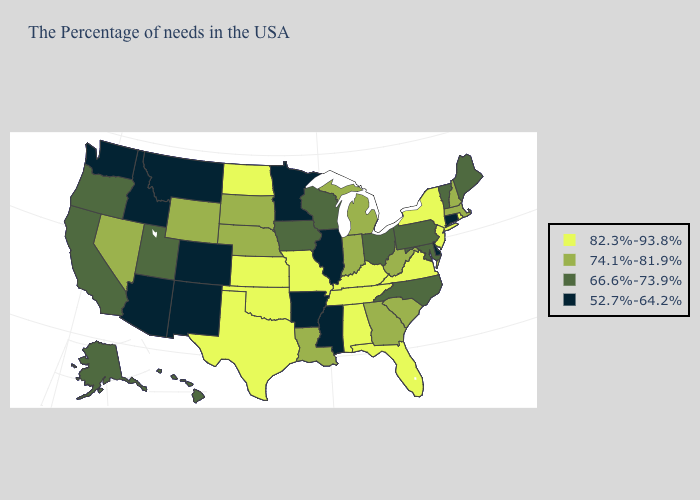What is the value of New Mexico?
Short answer required. 52.7%-64.2%. How many symbols are there in the legend?
Write a very short answer. 4. Among the states that border Connecticut , does New York have the highest value?
Answer briefly. Yes. Does Colorado have the highest value in the USA?
Keep it brief. No. Does the map have missing data?
Keep it brief. No. Does Oklahoma have the same value as Texas?
Give a very brief answer. Yes. Does Connecticut have the lowest value in the Northeast?
Give a very brief answer. Yes. Which states have the lowest value in the Northeast?
Answer briefly. Connecticut. How many symbols are there in the legend?
Concise answer only. 4. Name the states that have a value in the range 74.1%-81.9%?
Answer briefly. Massachusetts, New Hampshire, South Carolina, West Virginia, Georgia, Michigan, Indiana, Louisiana, Nebraska, South Dakota, Wyoming, Nevada. Among the states that border South Carolina , does North Carolina have the highest value?
Short answer required. No. Does the map have missing data?
Quick response, please. No. What is the value of Utah?
Quick response, please. 66.6%-73.9%. Name the states that have a value in the range 82.3%-93.8%?
Short answer required. Rhode Island, New York, New Jersey, Virginia, Florida, Kentucky, Alabama, Tennessee, Missouri, Kansas, Oklahoma, Texas, North Dakota. How many symbols are there in the legend?
Give a very brief answer. 4. 